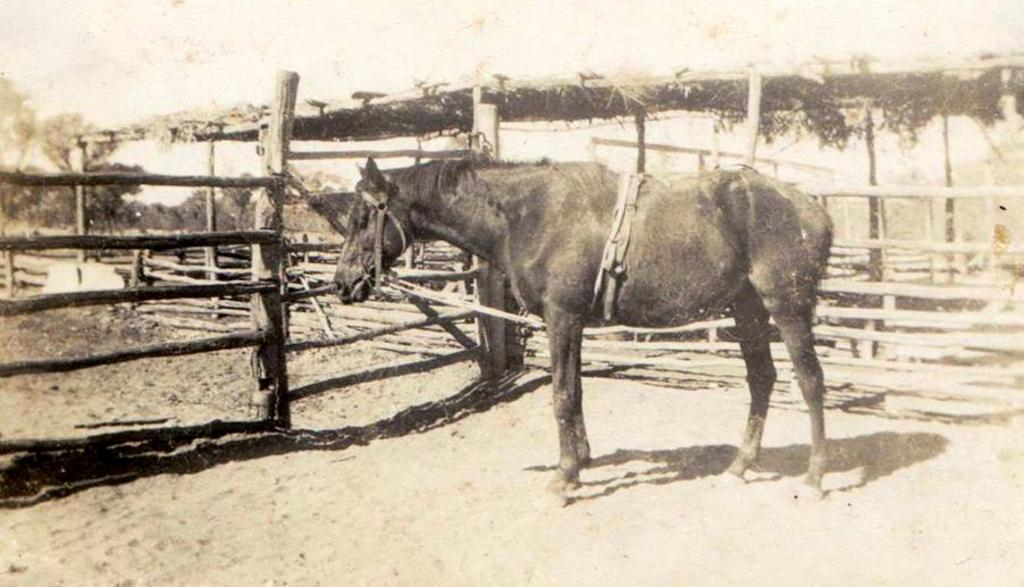What type of animal is in the image? There is a black horse in the image. What is at the bottom of the image? There is sand at the bottom of the image. What can be seen on the left side of the image? There is a wooden fencing on the left side of the image. What structure is visible in the background of the image? There is a hut in the background of the image. What type of milk is the horse drinking in the image? There is no milk present in the image, and the horse is not shown drinking anything. 